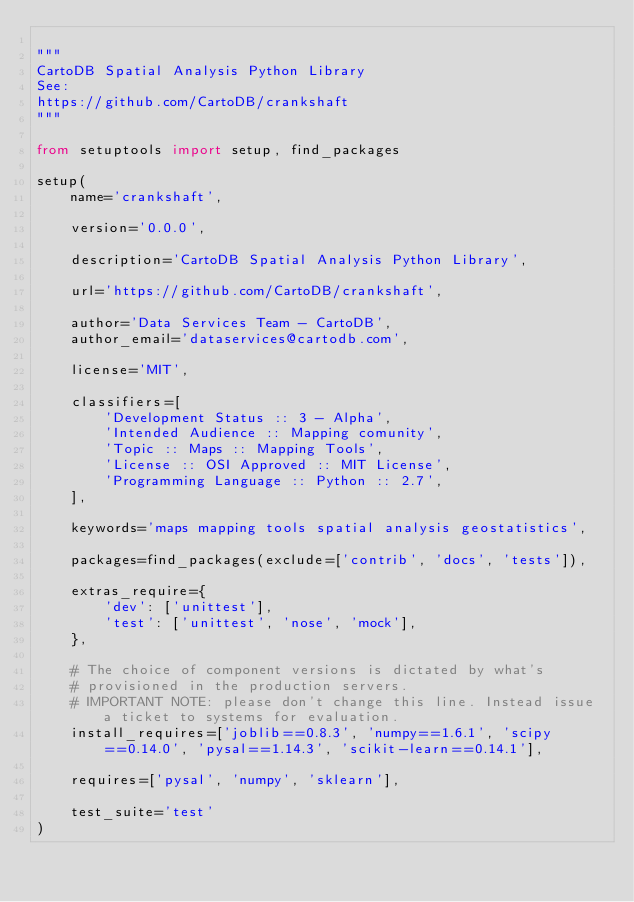<code> <loc_0><loc_0><loc_500><loc_500><_Python_>
"""
CartoDB Spatial Analysis Python Library
See:
https://github.com/CartoDB/crankshaft
"""

from setuptools import setup, find_packages

setup(
    name='crankshaft',

    version='0.0.0',

    description='CartoDB Spatial Analysis Python Library',

    url='https://github.com/CartoDB/crankshaft',

    author='Data Services Team - CartoDB',
    author_email='dataservices@cartodb.com',

    license='MIT',

    classifiers=[
        'Development Status :: 3 - Alpha',
        'Intended Audience :: Mapping comunity',
        'Topic :: Maps :: Mapping Tools',
        'License :: OSI Approved :: MIT License',
        'Programming Language :: Python :: 2.7',
    ],

    keywords='maps mapping tools spatial analysis geostatistics',

    packages=find_packages(exclude=['contrib', 'docs', 'tests']),

    extras_require={
        'dev': ['unittest'],
        'test': ['unittest', 'nose', 'mock'],
    },

    # The choice of component versions is dictated by what's
    # provisioned in the production servers.
    # IMPORTANT NOTE: please don't change this line. Instead issue a ticket to systems for evaluation.
    install_requires=['joblib==0.8.3', 'numpy==1.6.1', 'scipy==0.14.0', 'pysal==1.14.3', 'scikit-learn==0.14.1'],

    requires=['pysal', 'numpy', 'sklearn'],

    test_suite='test'
)
</code> 